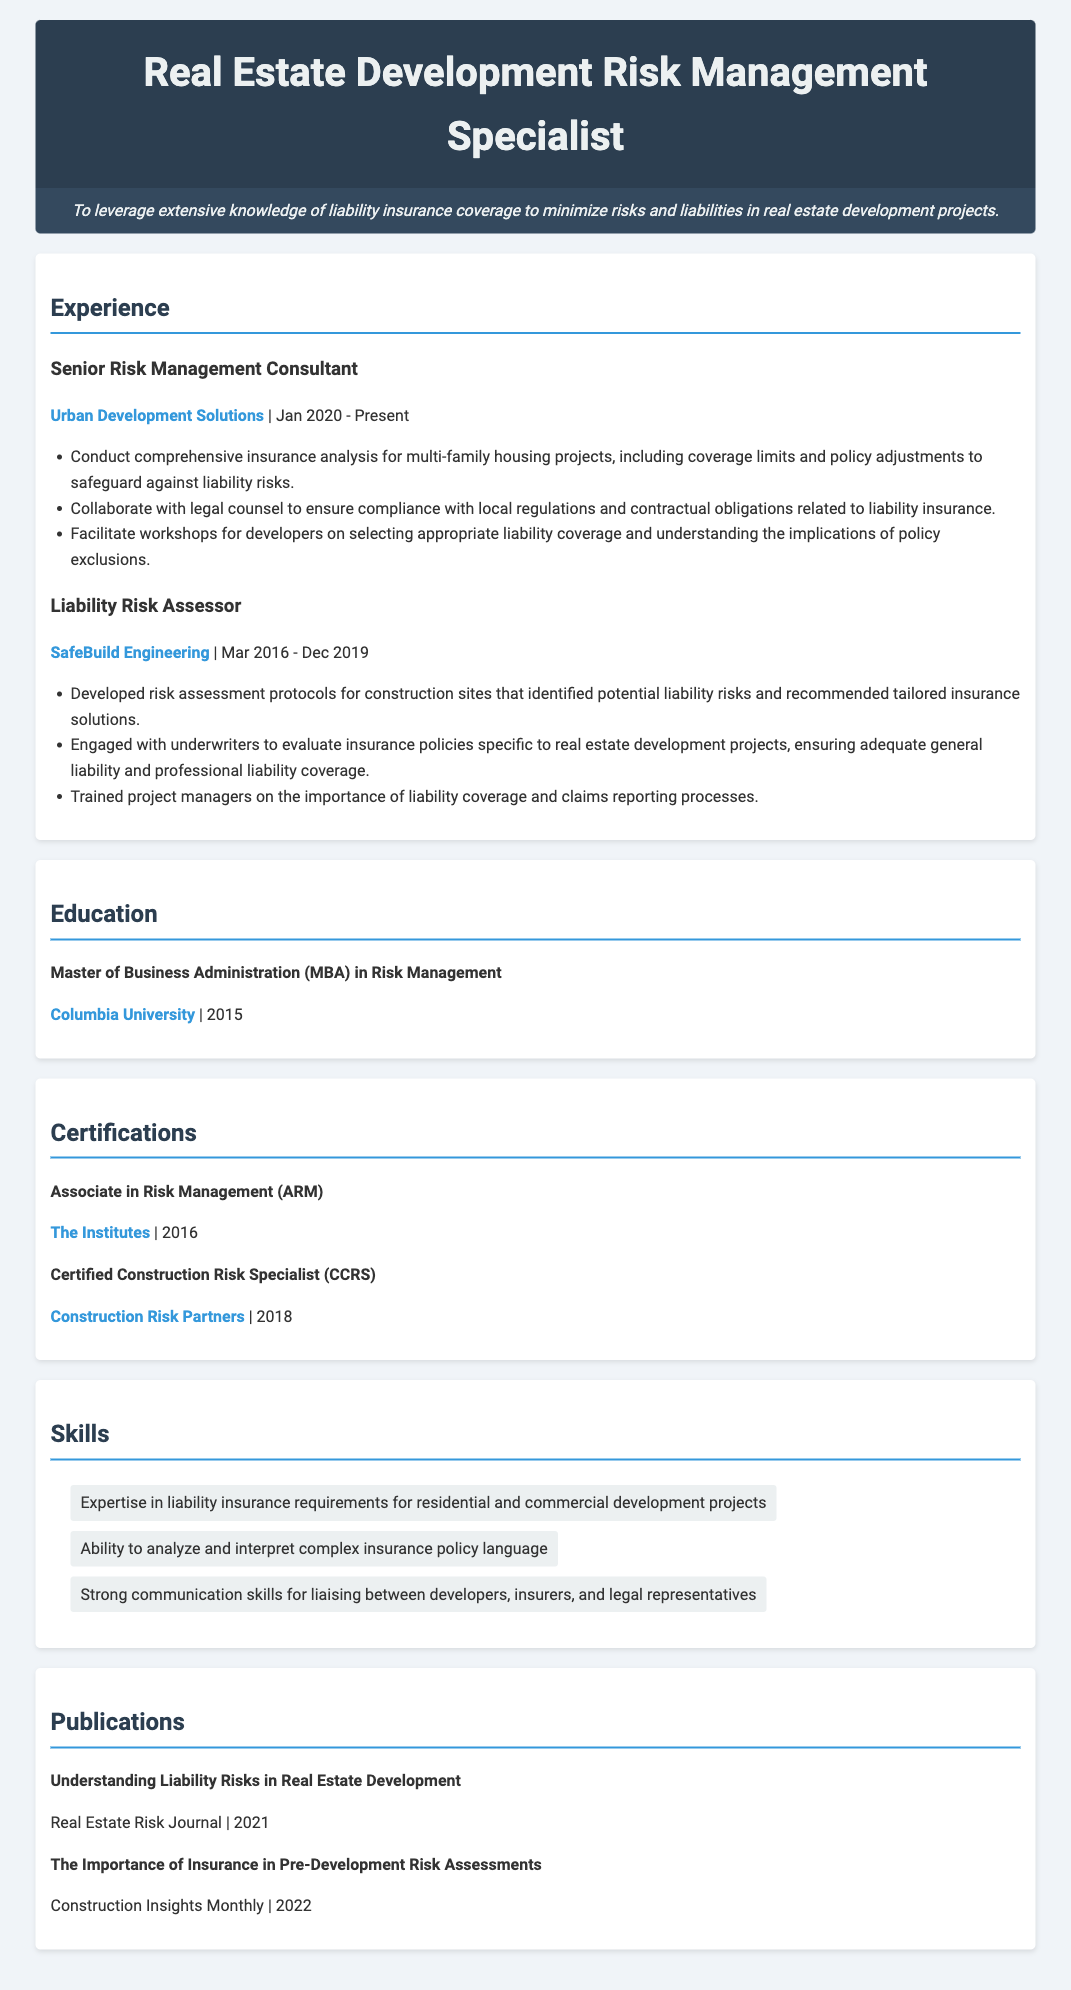what is the job title of the individual? The job title is listed at the top of the document in the header.
Answer: Real Estate Development Risk Management Specialist what is the name of the current employer? The current employer is mentioned under the experience section of the resume.
Answer: Urban Development Solutions when did the individual start their current role? The start date of the current role is provided in the experience section.
Answer: Jan 2020 which certification was obtained in 2016? The certification list specifies the year each certification was obtained.
Answer: Associate in Risk Management (ARM) how many years did the individual work as a Liability Risk Assessor? The duration of employment is calculated from the provided dates in the experience section.
Answer: 3 years what is one skill mentioned in the resume? The skills section lists various skills relevant to the role.
Answer: Expertise in liability insurance requirements for residential and commercial development projects which university did the individual attend for their MBA? The education section specifies the institution from where the degree was obtained.
Answer: Columbia University what publication was released in 2021? The publications section lists articles along with their publication dates.
Answer: Understanding Liability Risks in Real Estate Development what was the position before Senior Risk Management Consultant? The previous position is detailed in the experience section, showing the order of employment.
Answer: Liability Risk Assessor 